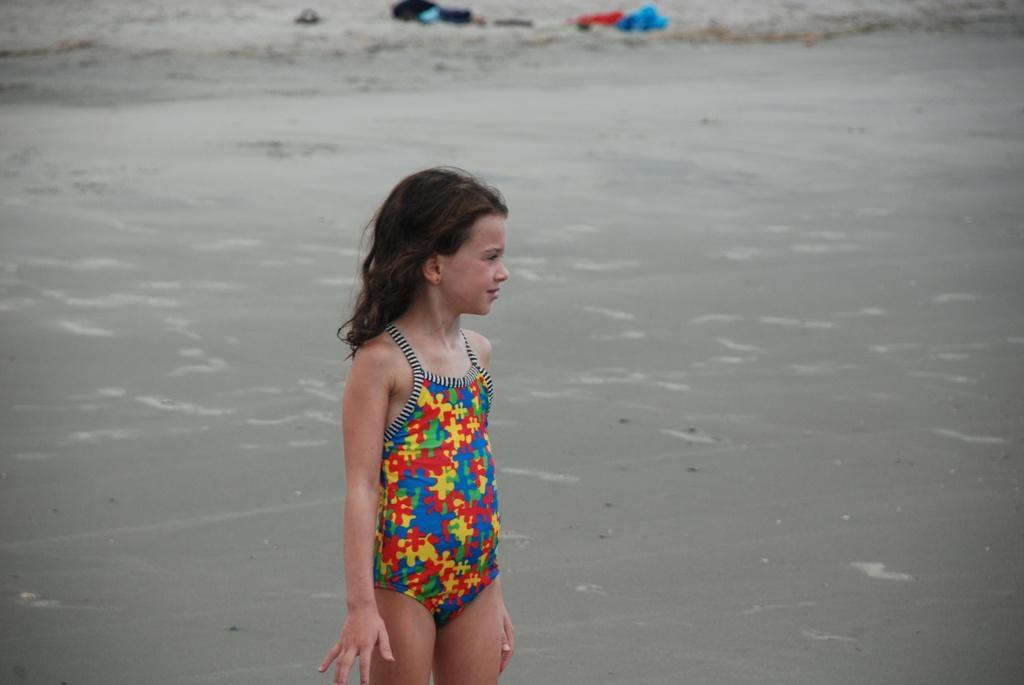How would you summarize this image in a sentence or two? There is a girl in a bikini, standing. In the background, there is water and there are clothes on the dry land. 